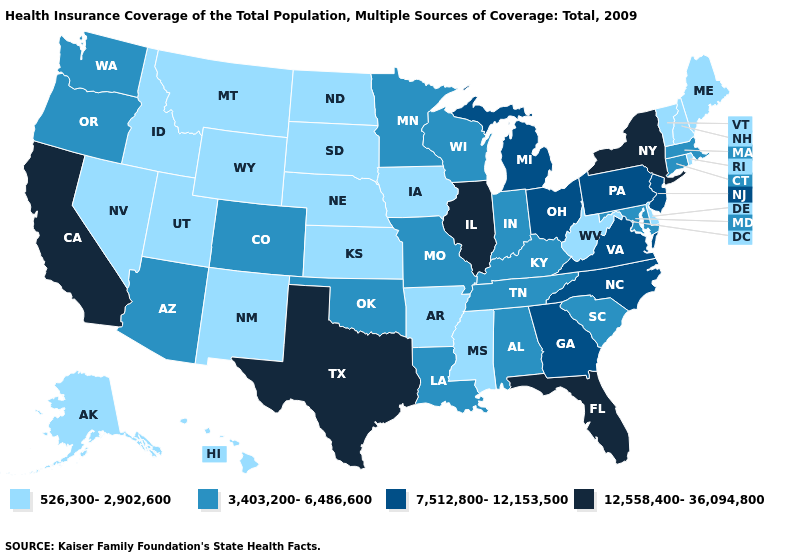Is the legend a continuous bar?
Quick response, please. No. Name the states that have a value in the range 526,300-2,902,600?
Answer briefly. Alaska, Arkansas, Delaware, Hawaii, Idaho, Iowa, Kansas, Maine, Mississippi, Montana, Nebraska, Nevada, New Hampshire, New Mexico, North Dakota, Rhode Island, South Dakota, Utah, Vermont, West Virginia, Wyoming. What is the lowest value in states that border Louisiana?
Short answer required. 526,300-2,902,600. Does Delaware have a higher value than North Dakota?
Keep it brief. No. What is the lowest value in states that border Missouri?
Short answer required. 526,300-2,902,600. Does the map have missing data?
Answer briefly. No. Does Illinois have the highest value in the MidWest?
Be succinct. Yes. Which states hav the highest value in the MidWest?
Be succinct. Illinois. Does Oregon have a lower value than South Carolina?
Quick response, please. No. What is the value of Arkansas?
Quick response, please. 526,300-2,902,600. What is the value of Texas?
Answer briefly. 12,558,400-36,094,800. Among the states that border Wisconsin , does Illinois have the highest value?
Be succinct. Yes. What is the lowest value in states that border Michigan?
Be succinct. 3,403,200-6,486,600. What is the value of West Virginia?
Short answer required. 526,300-2,902,600. What is the value of Missouri?
Be succinct. 3,403,200-6,486,600. 